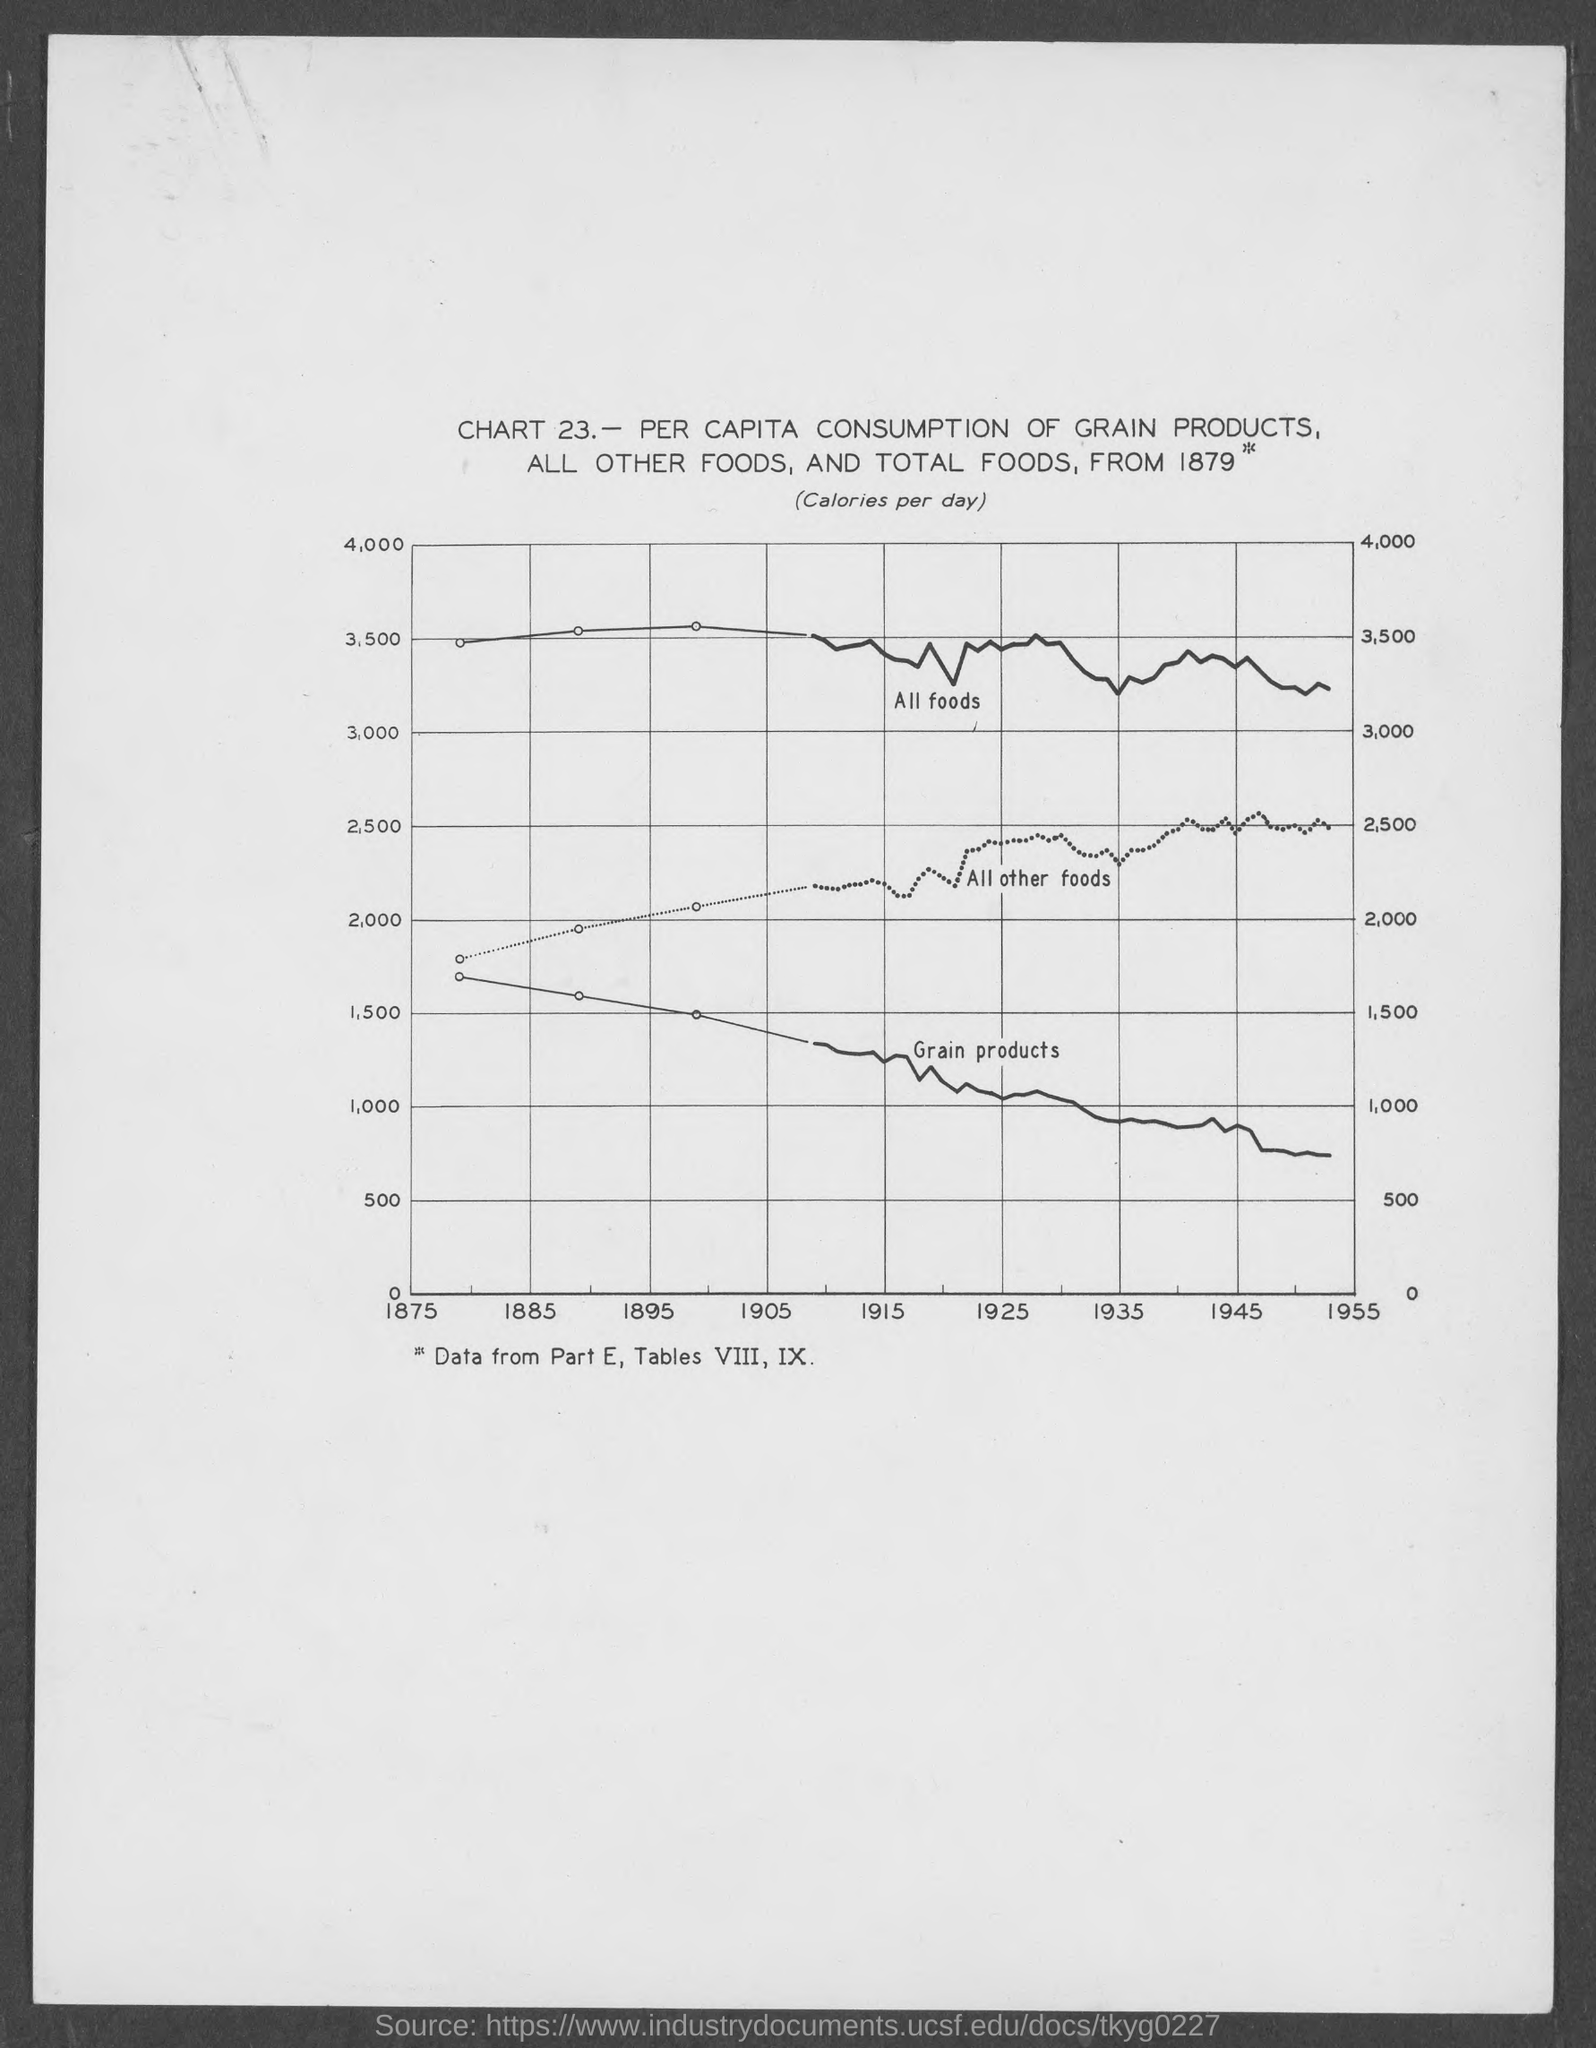Mention a couple of crucial points in this snapshot. The maximum value on the Y axis is 4,000. The first value on the X axis is 1875. The amount of calories per day is written within parentheses, just below the title. The topmost curve on the graph represents all types of food, including fruits, vegetables, and grains. 